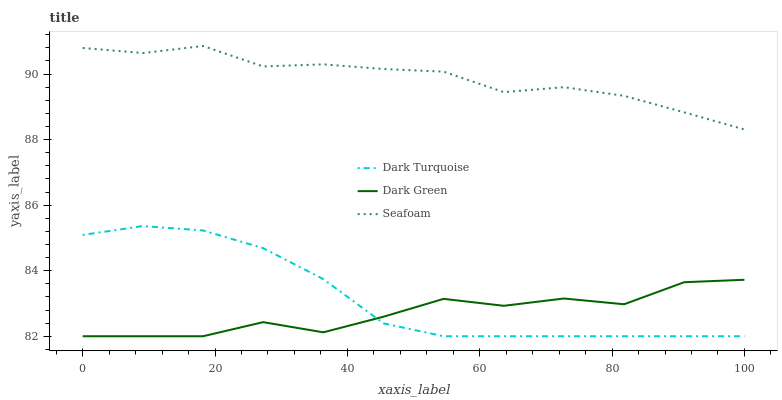Does Dark Green have the minimum area under the curve?
Answer yes or no. Yes. Does Seafoam have the maximum area under the curve?
Answer yes or no. Yes. Does Seafoam have the minimum area under the curve?
Answer yes or no. No. Does Dark Green have the maximum area under the curve?
Answer yes or no. No. Is Dark Turquoise the smoothest?
Answer yes or no. Yes. Is Dark Green the roughest?
Answer yes or no. Yes. Is Seafoam the smoothest?
Answer yes or no. No. Is Seafoam the roughest?
Answer yes or no. No. Does Dark Turquoise have the lowest value?
Answer yes or no. Yes. Does Seafoam have the lowest value?
Answer yes or no. No. Does Seafoam have the highest value?
Answer yes or no. Yes. Does Dark Green have the highest value?
Answer yes or no. No. Is Dark Turquoise less than Seafoam?
Answer yes or no. Yes. Is Seafoam greater than Dark Turquoise?
Answer yes or no. Yes. Does Dark Green intersect Dark Turquoise?
Answer yes or no. Yes. Is Dark Green less than Dark Turquoise?
Answer yes or no. No. Is Dark Green greater than Dark Turquoise?
Answer yes or no. No. Does Dark Turquoise intersect Seafoam?
Answer yes or no. No. 